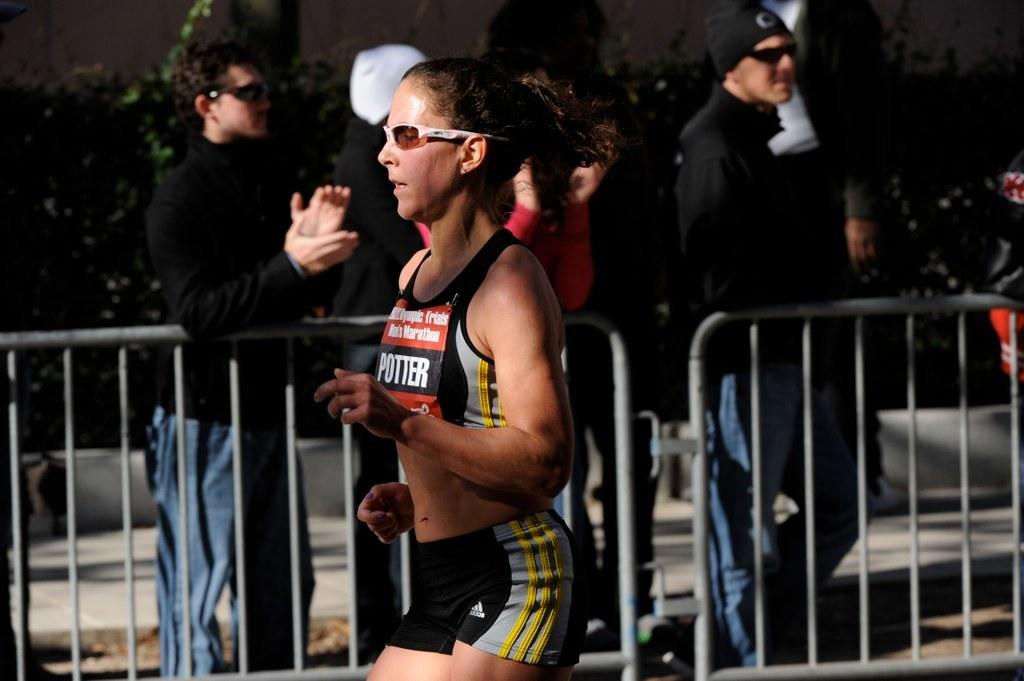<image>
Provide a brief description of the given image. A runner with the name POTTER on them. 